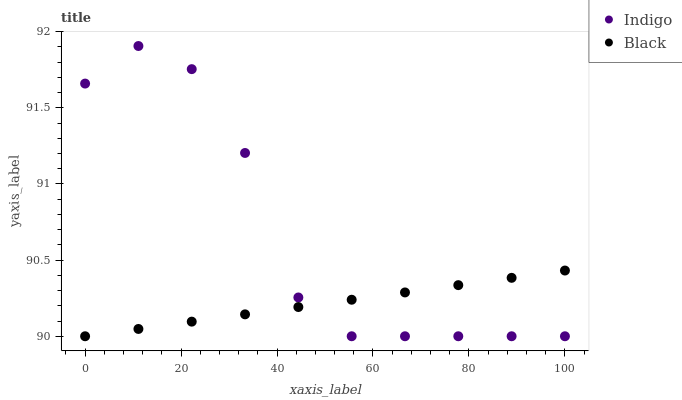Does Black have the minimum area under the curve?
Answer yes or no. Yes. Does Indigo have the maximum area under the curve?
Answer yes or no. Yes. Does Indigo have the minimum area under the curve?
Answer yes or no. No. Is Black the smoothest?
Answer yes or no. Yes. Is Indigo the roughest?
Answer yes or no. Yes. Is Indigo the smoothest?
Answer yes or no. No. Does Black have the lowest value?
Answer yes or no. Yes. Does Indigo have the highest value?
Answer yes or no. Yes. Does Black intersect Indigo?
Answer yes or no. Yes. Is Black less than Indigo?
Answer yes or no. No. Is Black greater than Indigo?
Answer yes or no. No. 